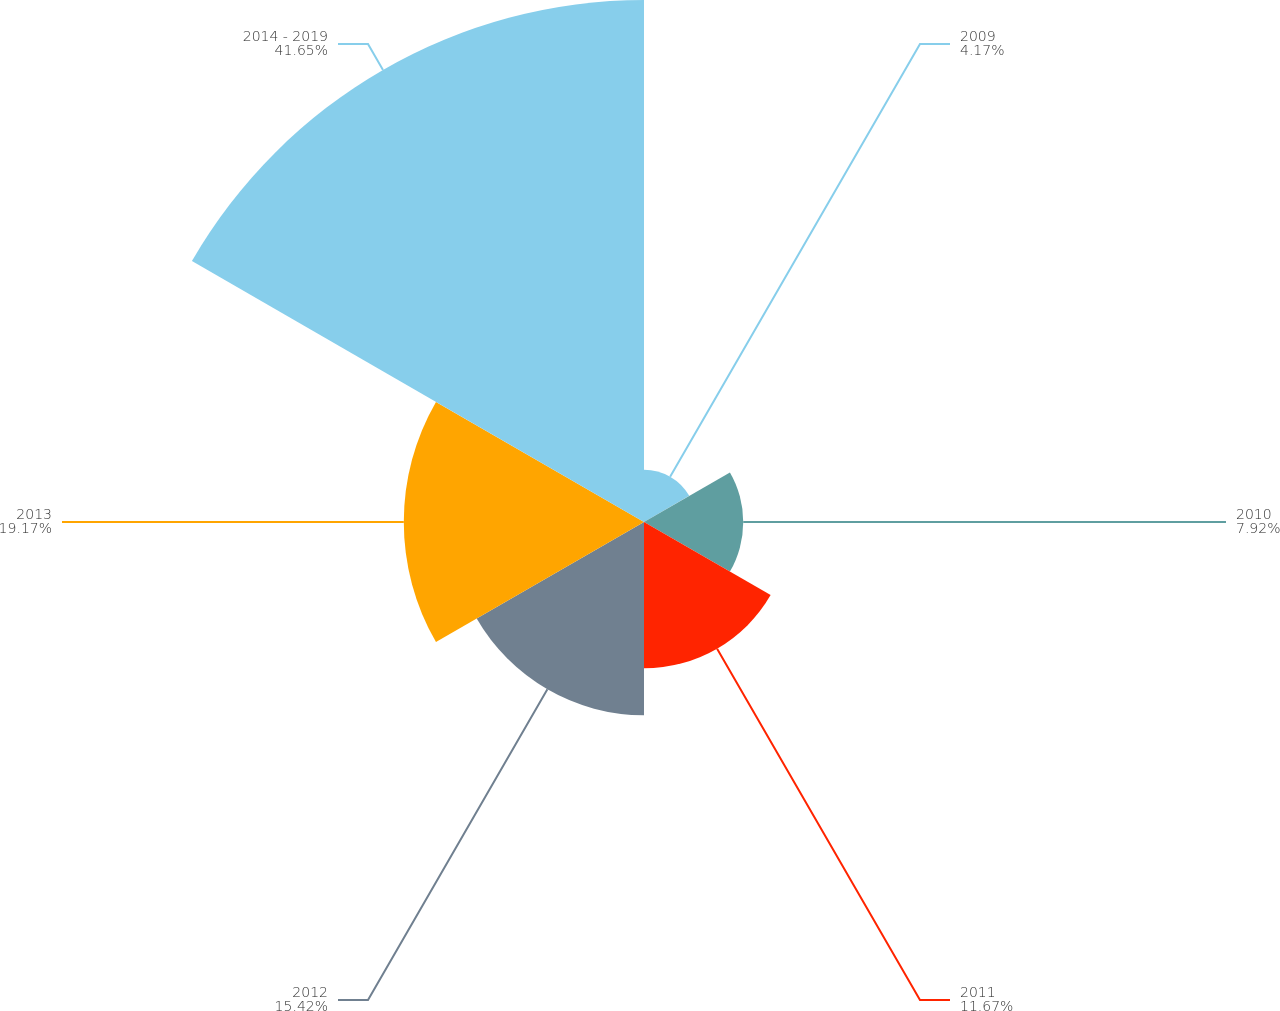Convert chart. <chart><loc_0><loc_0><loc_500><loc_500><pie_chart><fcel>2009<fcel>2010<fcel>2011<fcel>2012<fcel>2013<fcel>2014 - 2019<nl><fcel>4.17%<fcel>7.92%<fcel>11.67%<fcel>15.42%<fcel>19.17%<fcel>41.66%<nl></chart> 